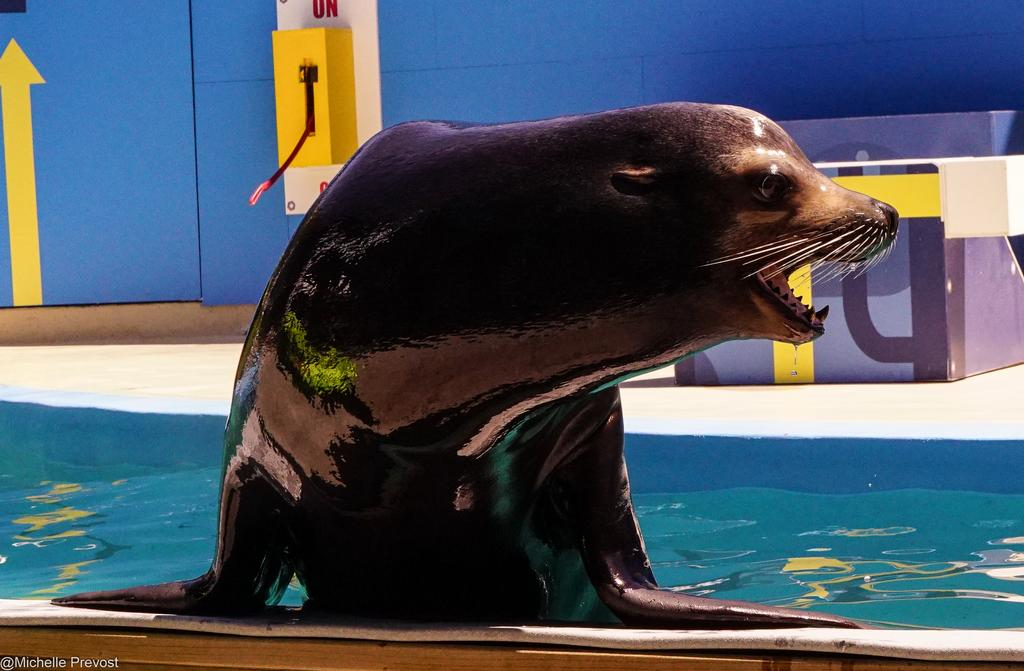What is the primary element in the image? There is water in the image. What type of creature can be seen in the water? There is a sea animal in the image. What can be seen in the background of the image? There is a wall and other objects in the background of the image. Where is the faucet located in the image? There is no faucet present in the image. What type of power source is used by the sea animal in the image? The image does not provide information about the sea animal's power source. 